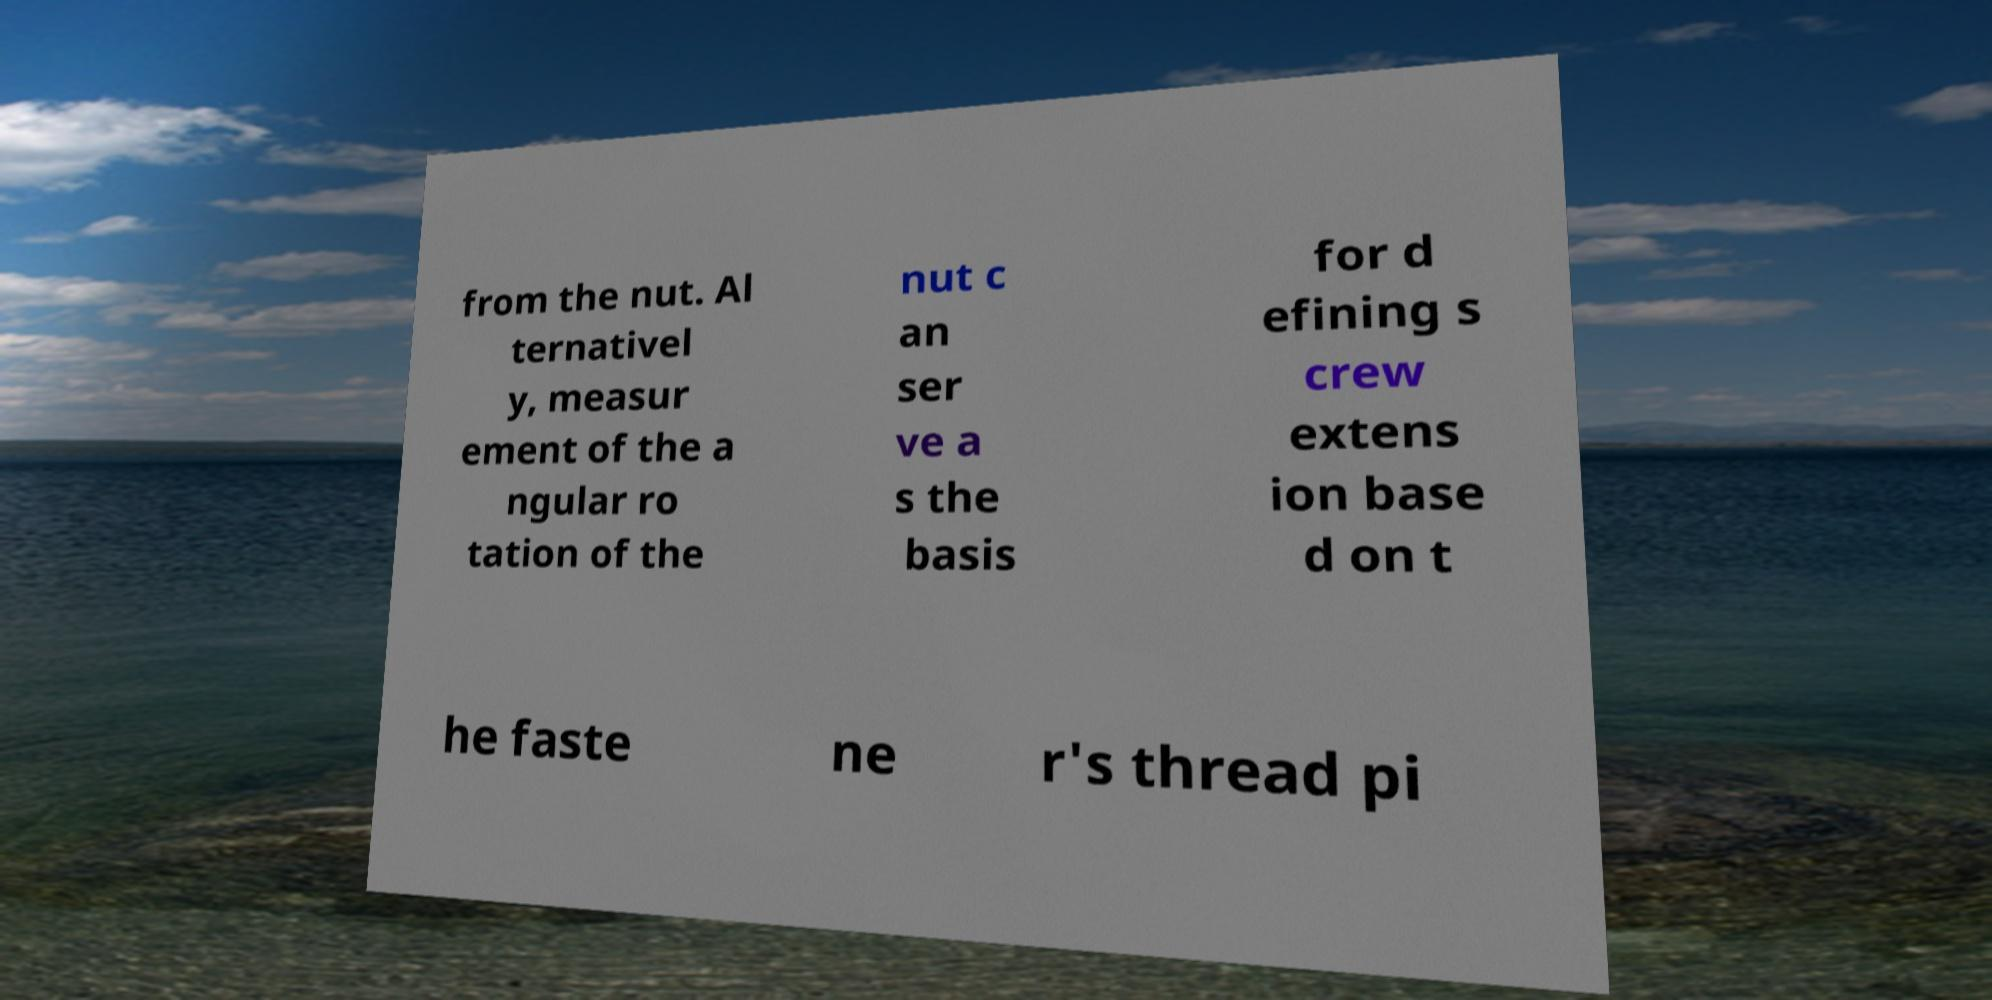Can you accurately transcribe the text from the provided image for me? from the nut. Al ternativel y, measur ement of the a ngular ro tation of the nut c an ser ve a s the basis for d efining s crew extens ion base d on t he faste ne r's thread pi 